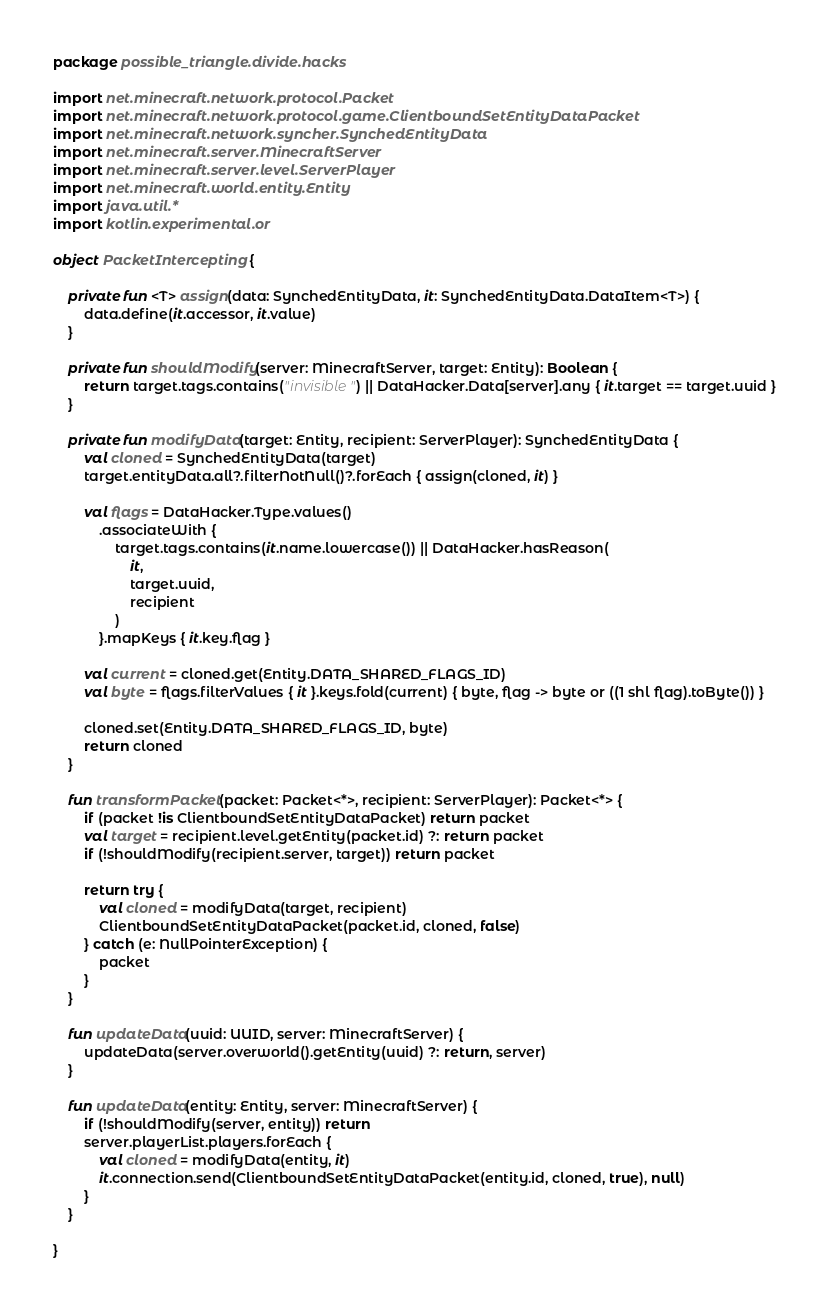<code> <loc_0><loc_0><loc_500><loc_500><_Kotlin_>package possible_triangle.divide.hacks

import net.minecraft.network.protocol.Packet
import net.minecraft.network.protocol.game.ClientboundSetEntityDataPacket
import net.minecraft.network.syncher.SynchedEntityData
import net.minecraft.server.MinecraftServer
import net.minecraft.server.level.ServerPlayer
import net.minecraft.world.entity.Entity
import java.util.*
import kotlin.experimental.or

object PacketIntercepting {

    private fun <T> assign(data: SynchedEntityData, it: SynchedEntityData.DataItem<T>) {
        data.define(it.accessor, it.value)
    }

    private fun shouldModify(server: MinecraftServer, target: Entity): Boolean {
        return target.tags.contains("invisible") || DataHacker.Data[server].any { it.target == target.uuid }
    }

    private fun modifyData(target: Entity, recipient: ServerPlayer): SynchedEntityData {
        val cloned = SynchedEntityData(target)
        target.entityData.all?.filterNotNull()?.forEach { assign(cloned, it) }

        val flags = DataHacker.Type.values()
            .associateWith {
                target.tags.contains(it.name.lowercase()) || DataHacker.hasReason(
                    it,
                    target.uuid,
                    recipient
                )
            }.mapKeys { it.key.flag }

        val current = cloned.get(Entity.DATA_SHARED_FLAGS_ID)
        val byte = flags.filterValues { it }.keys.fold(current) { byte, flag -> byte or ((1 shl flag).toByte()) }

        cloned.set(Entity.DATA_SHARED_FLAGS_ID, byte)
        return cloned
    }

    fun transformPacket(packet: Packet<*>, recipient: ServerPlayer): Packet<*> {
        if (packet !is ClientboundSetEntityDataPacket) return packet
        val target = recipient.level.getEntity(packet.id) ?: return packet
        if (!shouldModify(recipient.server, target)) return packet

        return try {
            val cloned = modifyData(target, recipient)
            ClientboundSetEntityDataPacket(packet.id, cloned, false)
        } catch (e: NullPointerException) {
            packet
        }
    }

    fun updateData(uuid: UUID, server: MinecraftServer) {
        updateData(server.overworld().getEntity(uuid) ?: return, server)
    }

    fun updateData(entity: Entity, server: MinecraftServer) {
        if (!shouldModify(server, entity)) return
        server.playerList.players.forEach {
            val cloned = modifyData(entity, it)
            it.connection.send(ClientboundSetEntityDataPacket(entity.id, cloned, true), null)
        }
    }

}</code> 